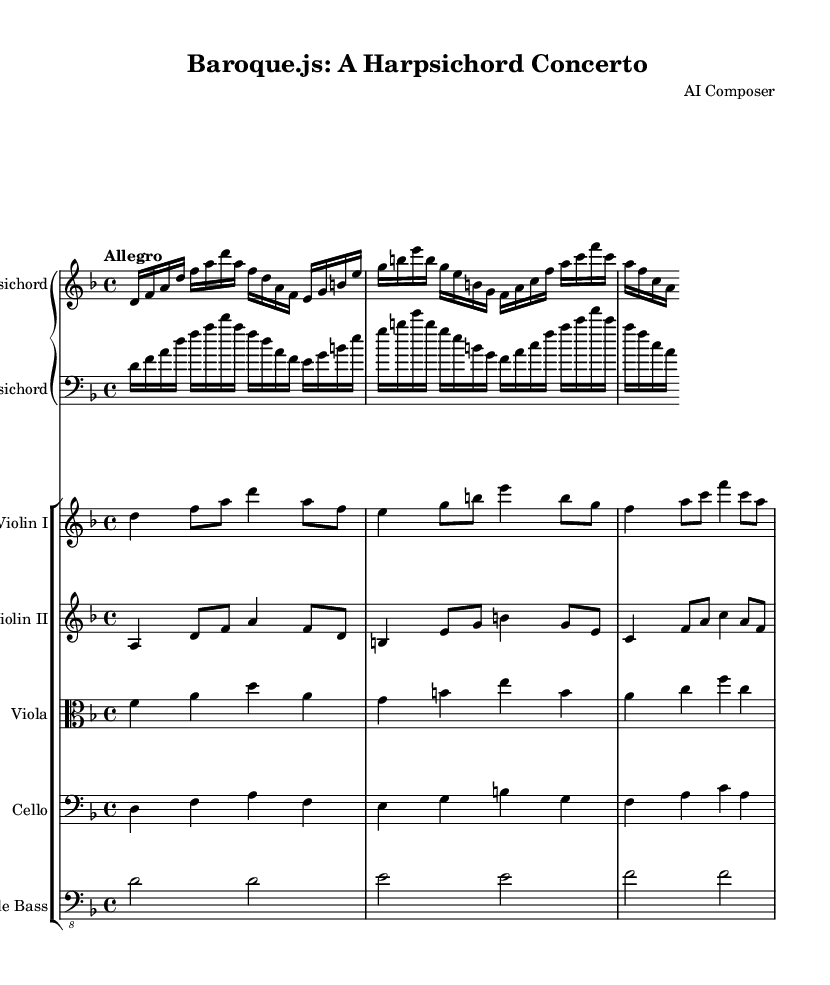What is the key signature of this music? The key signature is one flat, which indicates that the piece is in D minor. This is determined by looking at the key signature area at the beginning of the score.
Answer: D minor What is the time signature of the music? The time signature is 4/4, which is shown at the beginning of the score. It indicates that there are four beats in a measure and a quarter note receives one beat.
Answer: 4/4 What is the tempo marking for the concerto? The tempo marking is "Allegro," indicating a fast and lively pace. It is specified at the beginning of the piece, guiding the performance speed.
Answer: Allegro How many instruments are in this concerto? There are six instruments: harpsichord, two violins, viola, cello, and double bass. This is counted by identifying each staff in the score.
Answer: Six What is the instrument name for the left hand part in the harpsichord? The left hand part in the harpsichord is indicated as "bass" in the score, suggesting that the left hand is playing the lower parts while the right hand plays the melody.
Answer: bass Which instrument plays the second voice in harmony alongside Violin I? Violin II plays the second voice in harmony alongside Violin I. This is noted by the presence of the second violin part in the score.
Answer: Violin II In which musical period is this concerto written? The concerto is written in the Baroque period. This is inferred from the style of composition and the instruments used, which are characteristic of that era.
Answer: Baroque 